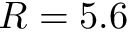Convert formula to latex. <formula><loc_0><loc_0><loc_500><loc_500>R = 5 . 6</formula> 